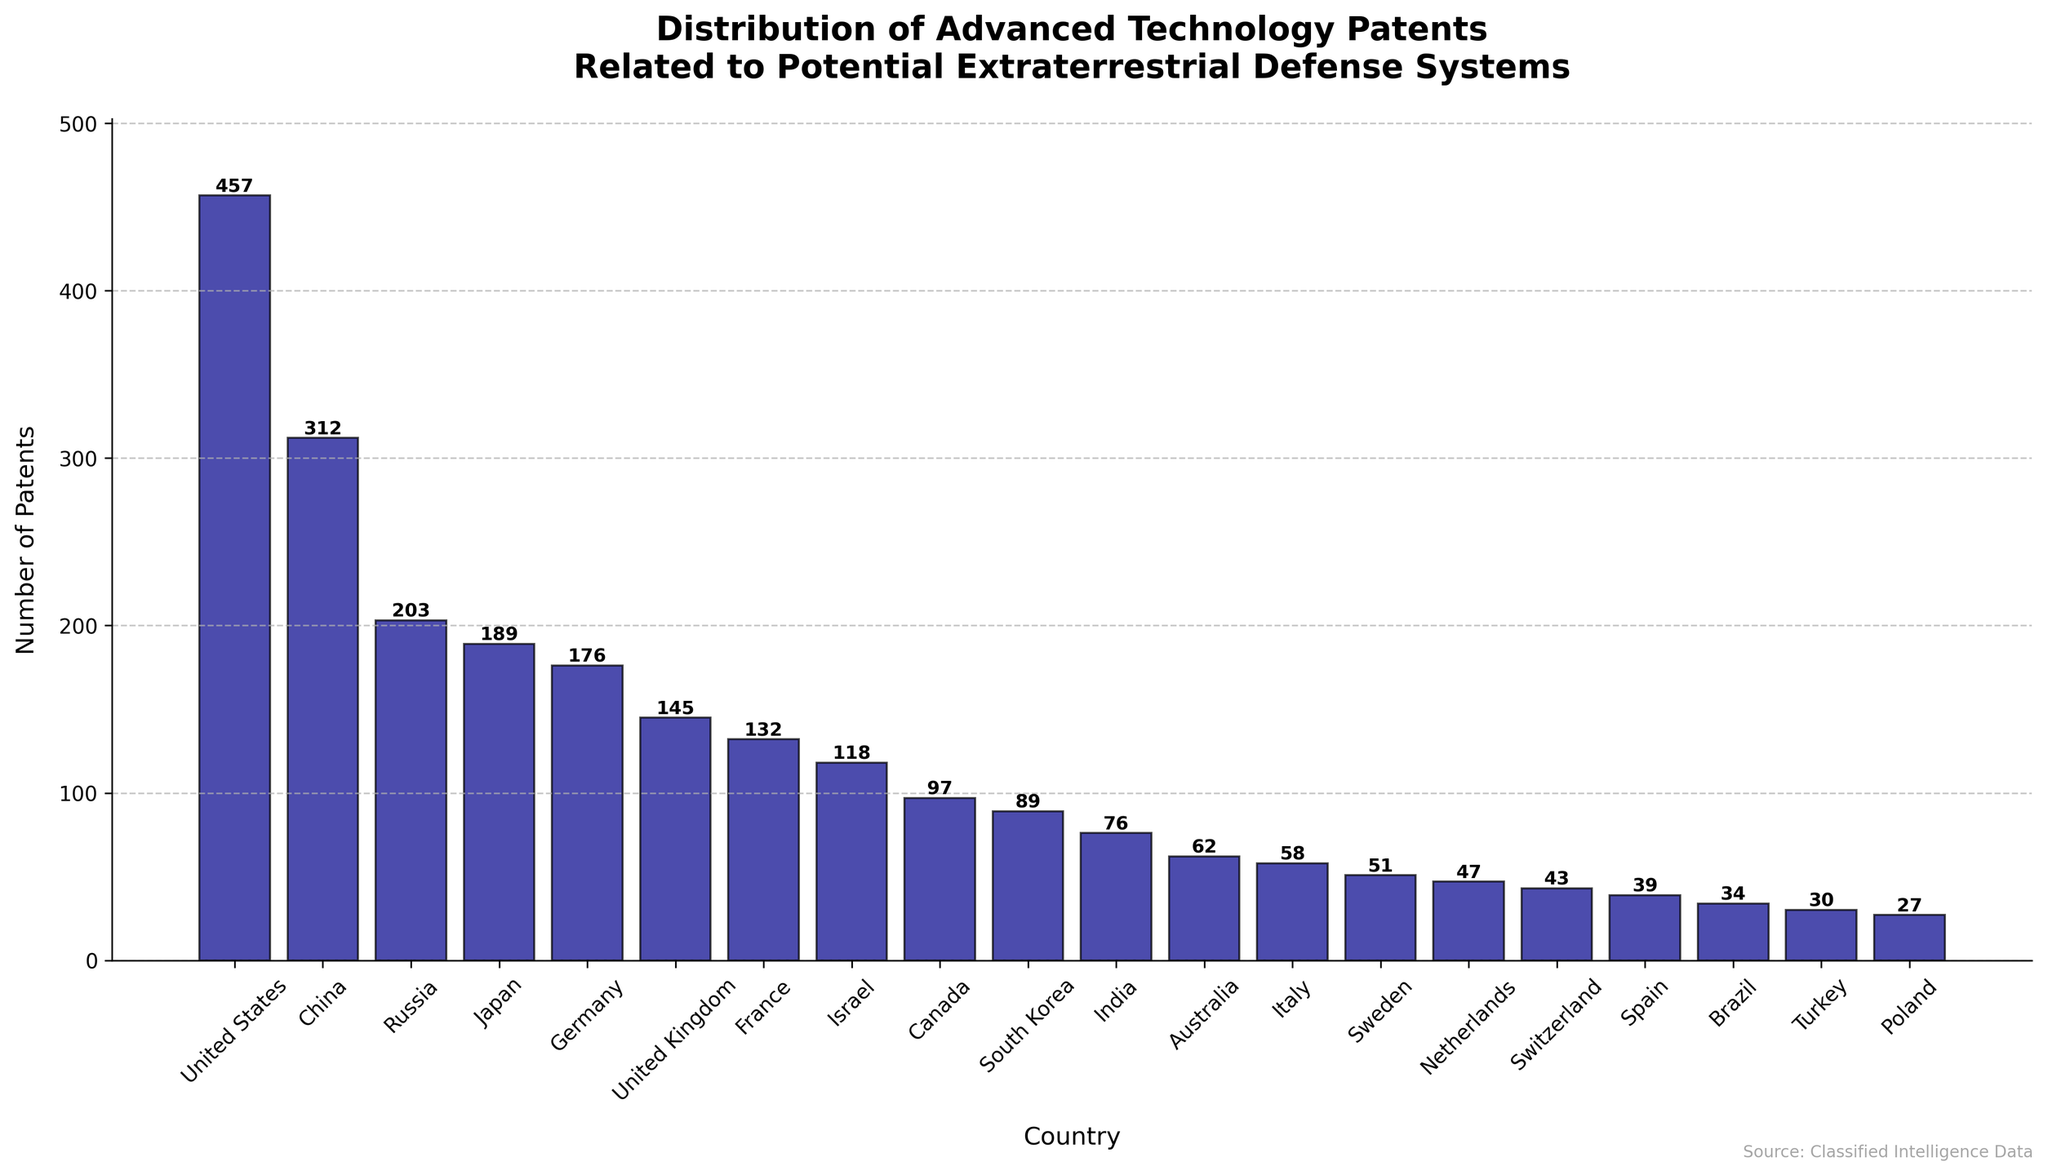Which country has the highest number of advanced ET defense patents? The figure shows the height of bars for each country. The tallest bar represents the United States.
Answer: United States How many more patents does the United States have than China? The height of the bar for the United States reads 457 patents, and the bar for China reads 312 patents. The difference is 457 - 312.
Answer: 145 What is the sum of patents for Germany, the United Kingdom, and France? Germany has 176 patents, the United Kingdom has 145 patents, and France has 132 patents. The sum is 176 + 145 + 132.
Answer: 453 Which countries have fewer than 100 advanced ET defense patents? The figure shows the bars for countries with patents less than 100: Canada (97), South Korea (89), India (76), Australia (62), Italy (58), Sweden (51), Netherlands (47), Switzerland (43), Spain (39), Brazil (34), Turkey (30), Poland (27).
Answer: Canada, South Korea, India, Australia, Italy, Sweden, Netherlands, Switzerland, Spain, Brazil, Turkey, Poland What is the average number of patents for the top 5 countries? The top 5 countries are the United States (457), China (312), Russia (203), Japan (189), and Germany (176). The average is (457 + 312 + 203 + 189 + 176) / 5.
Answer: 267.4 Which two countries have the closest number of patents? By comparing the heights of the bars, Japan (189) and Germany (176) have a difference of 189 - 176 = 13, which is the smallest difference among all countries.
Answer: Japan and Germany How many more patents do Japan and South Korea have together compared to Israel? Japan has 189 patents, South Korea has 89 patents, and Israel has 118 patents. The combined number for Japan and South Korea is 189 + 89 = 278. The difference is 278 - 118.
Answer: 160 What percentage of total patents is held by the United States? First, sum up the patents for all countries: 457 + 312 + 203 + 189 + 176 + 145 + 132 + 118 + 97 + 89 + 76 + 62 + 58 + 51 + 47 + 43 + 39 + 34 + 30 + 27 = 2,515. The percentage is (457 / 2,515) * 100%.
Answer: 18.17% How does the patent count for the United Kingdom compare to that of India? The United Kingdom has 145 patents, and India has 76 patents. The difference is 145 - 76.
Answer: 69 What is the median number of patents among all the countries? Arrange the countries by patents: 27, 30, 34, 39, 43, 47, 51, 58, 62, 76, 89, 97, 118, 132, 145, 176, 189, 203, 312, 457. The median is the average of the 10th and 11th values: (76 + 89) / 2.
Answer: 82.5 